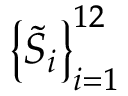<formula> <loc_0><loc_0><loc_500><loc_500>\left \{ \widetilde { S } _ { i } \right \} _ { i = 1 } ^ { 1 2 }</formula> 